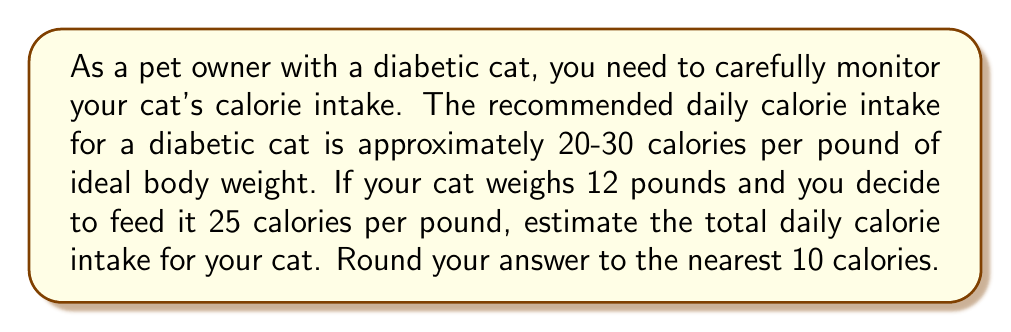Could you help me with this problem? To solve this problem, we'll follow these steps:

1. Identify the given information:
   - Recommended calorie intake: 20-30 calories per pound
   - Chosen calorie intake: 25 calories per pound
   - Cat's weight: 12 pounds

2. Calculate the daily calorie intake:
   Let $x$ be the daily calorie intake.
   $$x = \text{weight} \times \text{calories per pound}$$
   $$x = 12 \times 25 = 300 \text{ calories}$$

3. Round the result to the nearest 10 calories:
   300 is already a multiple of 10, so no rounding is necessary.

Therefore, the estimated daily calorie intake for your 12-pound diabetic cat is 300 calories.
Answer: $300 \text{ calories}$ 